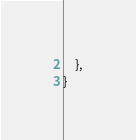Convert code to text. <code><loc_0><loc_0><loc_500><loc_500><_Rust_>    },
}
</code> 